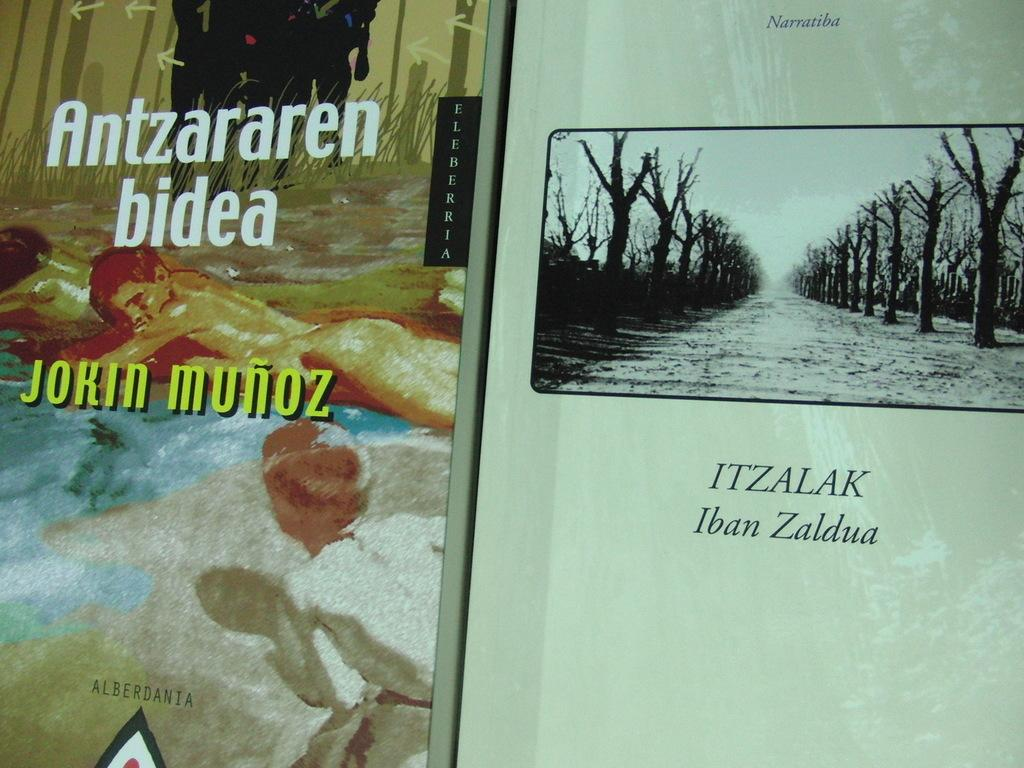What objects can be seen in the image? There are books in the image. What can be seen on the right side of the image? There are many trees on the right side of the image. How many people are visible in the image? There are two persons on the left side of the image. What is written on the books? There is text on the books. What color is the sock that one of the persons is wearing in the image? There is no sock mentioned or visible in the image. 